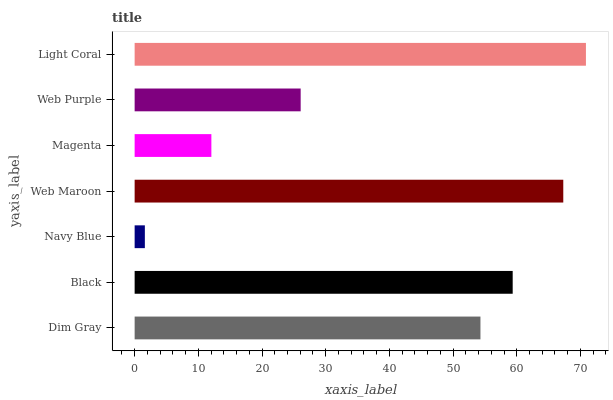Is Navy Blue the minimum?
Answer yes or no. Yes. Is Light Coral the maximum?
Answer yes or no. Yes. Is Black the minimum?
Answer yes or no. No. Is Black the maximum?
Answer yes or no. No. Is Black greater than Dim Gray?
Answer yes or no. Yes. Is Dim Gray less than Black?
Answer yes or no. Yes. Is Dim Gray greater than Black?
Answer yes or no. No. Is Black less than Dim Gray?
Answer yes or no. No. Is Dim Gray the high median?
Answer yes or no. Yes. Is Dim Gray the low median?
Answer yes or no. Yes. Is Magenta the high median?
Answer yes or no. No. Is Web Maroon the low median?
Answer yes or no. No. 